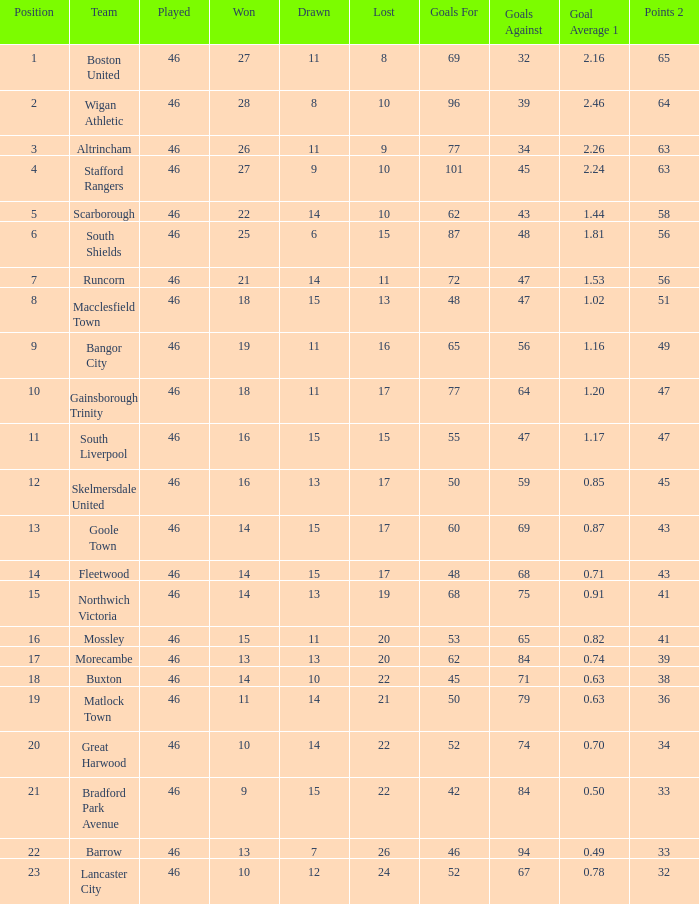How many games did the team who scored 60 goals win? 14.0. 